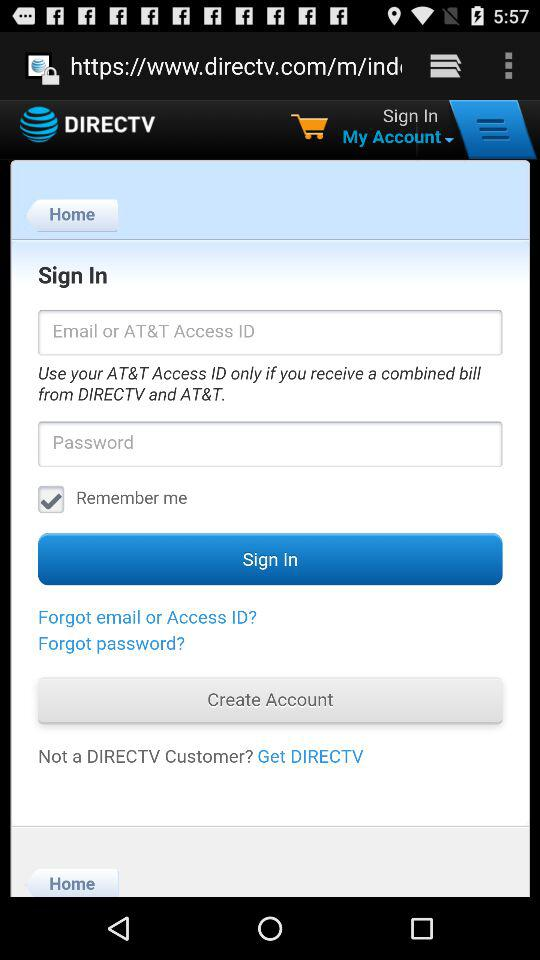What is the status of "Remember me"? The status is "on". 